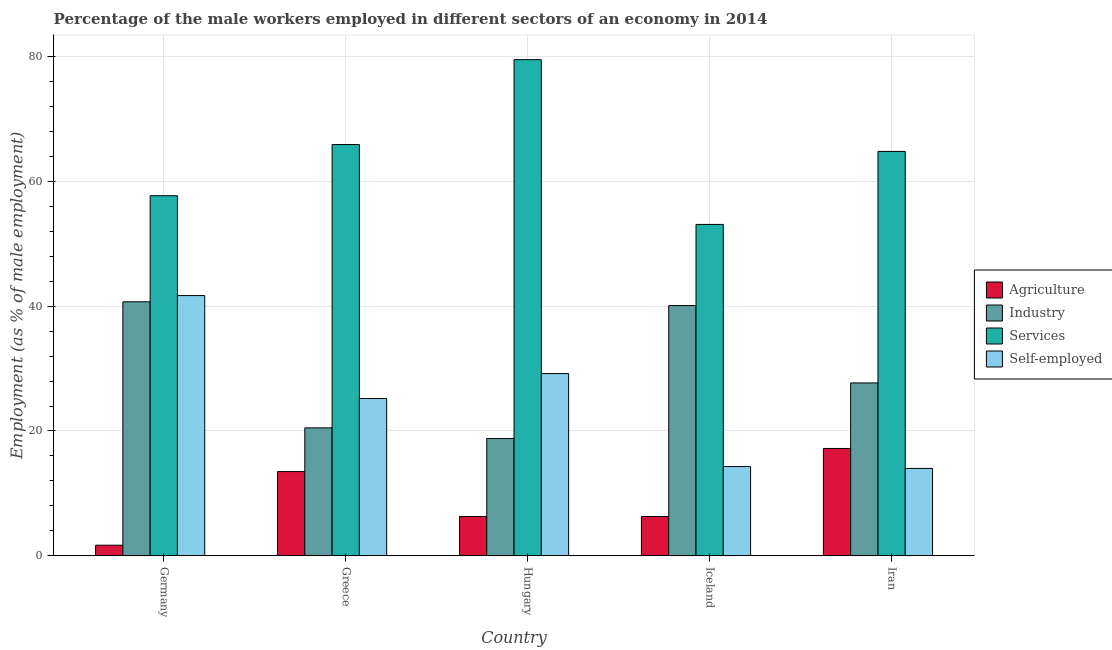How many different coloured bars are there?
Offer a very short reply. 4. Are the number of bars on each tick of the X-axis equal?
Provide a short and direct response. Yes. How many bars are there on the 3rd tick from the left?
Provide a succinct answer. 4. What is the label of the 2nd group of bars from the left?
Offer a very short reply. Greece. In how many cases, is the number of bars for a given country not equal to the number of legend labels?
Provide a short and direct response. 0. What is the percentage of male workers in industry in Iceland?
Offer a very short reply. 40.1. Across all countries, what is the maximum percentage of male workers in services?
Offer a terse response. 79.5. In which country was the percentage of male workers in agriculture maximum?
Your answer should be compact. Iran. What is the total percentage of male workers in industry in the graph?
Provide a succinct answer. 147.8. What is the difference between the percentage of male workers in industry in Iceland and that in Iran?
Your answer should be very brief. 12.4. What is the difference between the percentage of male workers in agriculture in Hungary and the percentage of self employed male workers in Germany?
Give a very brief answer. -35.4. What is the average percentage of self employed male workers per country?
Make the answer very short. 24.88. What is the difference between the percentage of male workers in industry and percentage of male workers in agriculture in Germany?
Give a very brief answer. 39. In how many countries, is the percentage of male workers in agriculture greater than 44 %?
Your answer should be compact. 0. What is the ratio of the percentage of male workers in agriculture in Greece to that in Iran?
Provide a short and direct response. 0.78. Is the percentage of male workers in agriculture in Greece less than that in Iran?
Your answer should be compact. Yes. What is the difference between the highest and the second highest percentage of male workers in industry?
Offer a terse response. 0.6. What is the difference between the highest and the lowest percentage of male workers in services?
Offer a very short reply. 26.4. In how many countries, is the percentage of self employed male workers greater than the average percentage of self employed male workers taken over all countries?
Your answer should be compact. 3. Is it the case that in every country, the sum of the percentage of male workers in industry and percentage of male workers in agriculture is greater than the sum of percentage of male workers in services and percentage of self employed male workers?
Provide a succinct answer. No. What does the 1st bar from the left in Germany represents?
Offer a very short reply. Agriculture. What does the 2nd bar from the right in Iceland represents?
Your answer should be very brief. Services. Is it the case that in every country, the sum of the percentage of male workers in agriculture and percentage of male workers in industry is greater than the percentage of male workers in services?
Give a very brief answer. No. How many countries are there in the graph?
Offer a very short reply. 5. Are the values on the major ticks of Y-axis written in scientific E-notation?
Give a very brief answer. No. Where does the legend appear in the graph?
Offer a very short reply. Center right. What is the title of the graph?
Your answer should be compact. Percentage of the male workers employed in different sectors of an economy in 2014. What is the label or title of the X-axis?
Your answer should be very brief. Country. What is the label or title of the Y-axis?
Offer a very short reply. Employment (as % of male employment). What is the Employment (as % of male employment) in Agriculture in Germany?
Provide a short and direct response. 1.7. What is the Employment (as % of male employment) in Industry in Germany?
Make the answer very short. 40.7. What is the Employment (as % of male employment) in Services in Germany?
Make the answer very short. 57.7. What is the Employment (as % of male employment) of Self-employed in Germany?
Offer a very short reply. 41.7. What is the Employment (as % of male employment) of Agriculture in Greece?
Make the answer very short. 13.5. What is the Employment (as % of male employment) of Industry in Greece?
Offer a very short reply. 20.5. What is the Employment (as % of male employment) in Services in Greece?
Your response must be concise. 65.9. What is the Employment (as % of male employment) of Self-employed in Greece?
Make the answer very short. 25.2. What is the Employment (as % of male employment) in Agriculture in Hungary?
Your answer should be compact. 6.3. What is the Employment (as % of male employment) of Industry in Hungary?
Offer a terse response. 18.8. What is the Employment (as % of male employment) in Services in Hungary?
Your response must be concise. 79.5. What is the Employment (as % of male employment) of Self-employed in Hungary?
Your answer should be compact. 29.2. What is the Employment (as % of male employment) of Agriculture in Iceland?
Give a very brief answer. 6.3. What is the Employment (as % of male employment) in Industry in Iceland?
Offer a very short reply. 40.1. What is the Employment (as % of male employment) of Services in Iceland?
Your answer should be compact. 53.1. What is the Employment (as % of male employment) of Self-employed in Iceland?
Offer a terse response. 14.3. What is the Employment (as % of male employment) in Agriculture in Iran?
Keep it short and to the point. 17.2. What is the Employment (as % of male employment) of Industry in Iran?
Give a very brief answer. 27.7. What is the Employment (as % of male employment) in Services in Iran?
Provide a succinct answer. 64.8. What is the Employment (as % of male employment) of Self-employed in Iran?
Keep it short and to the point. 14. Across all countries, what is the maximum Employment (as % of male employment) in Agriculture?
Make the answer very short. 17.2. Across all countries, what is the maximum Employment (as % of male employment) of Industry?
Ensure brevity in your answer.  40.7. Across all countries, what is the maximum Employment (as % of male employment) in Services?
Ensure brevity in your answer.  79.5. Across all countries, what is the maximum Employment (as % of male employment) of Self-employed?
Offer a terse response. 41.7. Across all countries, what is the minimum Employment (as % of male employment) in Agriculture?
Your answer should be compact. 1.7. Across all countries, what is the minimum Employment (as % of male employment) of Industry?
Your response must be concise. 18.8. Across all countries, what is the minimum Employment (as % of male employment) in Services?
Your response must be concise. 53.1. Across all countries, what is the minimum Employment (as % of male employment) of Self-employed?
Provide a short and direct response. 14. What is the total Employment (as % of male employment) in Industry in the graph?
Your answer should be very brief. 147.8. What is the total Employment (as % of male employment) of Services in the graph?
Give a very brief answer. 321. What is the total Employment (as % of male employment) in Self-employed in the graph?
Offer a terse response. 124.4. What is the difference between the Employment (as % of male employment) of Agriculture in Germany and that in Greece?
Provide a short and direct response. -11.8. What is the difference between the Employment (as % of male employment) of Industry in Germany and that in Greece?
Offer a terse response. 20.2. What is the difference between the Employment (as % of male employment) in Services in Germany and that in Greece?
Keep it short and to the point. -8.2. What is the difference between the Employment (as % of male employment) in Self-employed in Germany and that in Greece?
Give a very brief answer. 16.5. What is the difference between the Employment (as % of male employment) of Industry in Germany and that in Hungary?
Keep it short and to the point. 21.9. What is the difference between the Employment (as % of male employment) in Services in Germany and that in Hungary?
Provide a short and direct response. -21.8. What is the difference between the Employment (as % of male employment) of Self-employed in Germany and that in Iceland?
Provide a succinct answer. 27.4. What is the difference between the Employment (as % of male employment) in Agriculture in Germany and that in Iran?
Keep it short and to the point. -15.5. What is the difference between the Employment (as % of male employment) of Industry in Germany and that in Iran?
Offer a terse response. 13. What is the difference between the Employment (as % of male employment) of Self-employed in Germany and that in Iran?
Offer a very short reply. 27.7. What is the difference between the Employment (as % of male employment) in Services in Greece and that in Hungary?
Offer a terse response. -13.6. What is the difference between the Employment (as % of male employment) of Self-employed in Greece and that in Hungary?
Provide a short and direct response. -4. What is the difference between the Employment (as % of male employment) of Industry in Greece and that in Iceland?
Give a very brief answer. -19.6. What is the difference between the Employment (as % of male employment) in Services in Greece and that in Iceland?
Keep it short and to the point. 12.8. What is the difference between the Employment (as % of male employment) of Agriculture in Greece and that in Iran?
Provide a succinct answer. -3.7. What is the difference between the Employment (as % of male employment) of Industry in Greece and that in Iran?
Ensure brevity in your answer.  -7.2. What is the difference between the Employment (as % of male employment) in Self-employed in Greece and that in Iran?
Your answer should be compact. 11.2. What is the difference between the Employment (as % of male employment) in Industry in Hungary and that in Iceland?
Make the answer very short. -21.3. What is the difference between the Employment (as % of male employment) of Services in Hungary and that in Iceland?
Provide a short and direct response. 26.4. What is the difference between the Employment (as % of male employment) of Self-employed in Hungary and that in Iceland?
Keep it short and to the point. 14.9. What is the difference between the Employment (as % of male employment) of Self-employed in Hungary and that in Iran?
Provide a short and direct response. 15.2. What is the difference between the Employment (as % of male employment) of Self-employed in Iceland and that in Iran?
Your answer should be very brief. 0.3. What is the difference between the Employment (as % of male employment) in Agriculture in Germany and the Employment (as % of male employment) in Industry in Greece?
Make the answer very short. -18.8. What is the difference between the Employment (as % of male employment) of Agriculture in Germany and the Employment (as % of male employment) of Services in Greece?
Offer a terse response. -64.2. What is the difference between the Employment (as % of male employment) of Agriculture in Germany and the Employment (as % of male employment) of Self-employed in Greece?
Your answer should be very brief. -23.5. What is the difference between the Employment (as % of male employment) of Industry in Germany and the Employment (as % of male employment) of Services in Greece?
Your response must be concise. -25.2. What is the difference between the Employment (as % of male employment) in Services in Germany and the Employment (as % of male employment) in Self-employed in Greece?
Provide a succinct answer. 32.5. What is the difference between the Employment (as % of male employment) in Agriculture in Germany and the Employment (as % of male employment) in Industry in Hungary?
Offer a very short reply. -17.1. What is the difference between the Employment (as % of male employment) of Agriculture in Germany and the Employment (as % of male employment) of Services in Hungary?
Provide a short and direct response. -77.8. What is the difference between the Employment (as % of male employment) in Agriculture in Germany and the Employment (as % of male employment) in Self-employed in Hungary?
Provide a short and direct response. -27.5. What is the difference between the Employment (as % of male employment) in Industry in Germany and the Employment (as % of male employment) in Services in Hungary?
Your answer should be compact. -38.8. What is the difference between the Employment (as % of male employment) of Services in Germany and the Employment (as % of male employment) of Self-employed in Hungary?
Keep it short and to the point. 28.5. What is the difference between the Employment (as % of male employment) in Agriculture in Germany and the Employment (as % of male employment) in Industry in Iceland?
Provide a short and direct response. -38.4. What is the difference between the Employment (as % of male employment) of Agriculture in Germany and the Employment (as % of male employment) of Services in Iceland?
Keep it short and to the point. -51.4. What is the difference between the Employment (as % of male employment) in Agriculture in Germany and the Employment (as % of male employment) in Self-employed in Iceland?
Your answer should be compact. -12.6. What is the difference between the Employment (as % of male employment) in Industry in Germany and the Employment (as % of male employment) in Self-employed in Iceland?
Offer a terse response. 26.4. What is the difference between the Employment (as % of male employment) of Services in Germany and the Employment (as % of male employment) of Self-employed in Iceland?
Provide a succinct answer. 43.4. What is the difference between the Employment (as % of male employment) in Agriculture in Germany and the Employment (as % of male employment) in Services in Iran?
Your answer should be compact. -63.1. What is the difference between the Employment (as % of male employment) in Agriculture in Germany and the Employment (as % of male employment) in Self-employed in Iran?
Ensure brevity in your answer.  -12.3. What is the difference between the Employment (as % of male employment) in Industry in Germany and the Employment (as % of male employment) in Services in Iran?
Provide a succinct answer. -24.1. What is the difference between the Employment (as % of male employment) in Industry in Germany and the Employment (as % of male employment) in Self-employed in Iran?
Offer a terse response. 26.7. What is the difference between the Employment (as % of male employment) in Services in Germany and the Employment (as % of male employment) in Self-employed in Iran?
Give a very brief answer. 43.7. What is the difference between the Employment (as % of male employment) of Agriculture in Greece and the Employment (as % of male employment) of Services in Hungary?
Offer a very short reply. -66. What is the difference between the Employment (as % of male employment) of Agriculture in Greece and the Employment (as % of male employment) of Self-employed in Hungary?
Provide a succinct answer. -15.7. What is the difference between the Employment (as % of male employment) in Industry in Greece and the Employment (as % of male employment) in Services in Hungary?
Your response must be concise. -59. What is the difference between the Employment (as % of male employment) in Industry in Greece and the Employment (as % of male employment) in Self-employed in Hungary?
Offer a terse response. -8.7. What is the difference between the Employment (as % of male employment) in Services in Greece and the Employment (as % of male employment) in Self-employed in Hungary?
Offer a very short reply. 36.7. What is the difference between the Employment (as % of male employment) in Agriculture in Greece and the Employment (as % of male employment) in Industry in Iceland?
Make the answer very short. -26.6. What is the difference between the Employment (as % of male employment) of Agriculture in Greece and the Employment (as % of male employment) of Services in Iceland?
Provide a short and direct response. -39.6. What is the difference between the Employment (as % of male employment) in Agriculture in Greece and the Employment (as % of male employment) in Self-employed in Iceland?
Keep it short and to the point. -0.8. What is the difference between the Employment (as % of male employment) in Industry in Greece and the Employment (as % of male employment) in Services in Iceland?
Give a very brief answer. -32.6. What is the difference between the Employment (as % of male employment) of Industry in Greece and the Employment (as % of male employment) of Self-employed in Iceland?
Your answer should be compact. 6.2. What is the difference between the Employment (as % of male employment) of Services in Greece and the Employment (as % of male employment) of Self-employed in Iceland?
Provide a short and direct response. 51.6. What is the difference between the Employment (as % of male employment) in Agriculture in Greece and the Employment (as % of male employment) in Industry in Iran?
Provide a short and direct response. -14.2. What is the difference between the Employment (as % of male employment) in Agriculture in Greece and the Employment (as % of male employment) in Services in Iran?
Your answer should be compact. -51.3. What is the difference between the Employment (as % of male employment) of Agriculture in Greece and the Employment (as % of male employment) of Self-employed in Iran?
Your response must be concise. -0.5. What is the difference between the Employment (as % of male employment) in Industry in Greece and the Employment (as % of male employment) in Services in Iran?
Your answer should be very brief. -44.3. What is the difference between the Employment (as % of male employment) in Services in Greece and the Employment (as % of male employment) in Self-employed in Iran?
Your answer should be compact. 51.9. What is the difference between the Employment (as % of male employment) of Agriculture in Hungary and the Employment (as % of male employment) of Industry in Iceland?
Make the answer very short. -33.8. What is the difference between the Employment (as % of male employment) in Agriculture in Hungary and the Employment (as % of male employment) in Services in Iceland?
Keep it short and to the point. -46.8. What is the difference between the Employment (as % of male employment) of Agriculture in Hungary and the Employment (as % of male employment) of Self-employed in Iceland?
Provide a short and direct response. -8. What is the difference between the Employment (as % of male employment) of Industry in Hungary and the Employment (as % of male employment) of Services in Iceland?
Provide a short and direct response. -34.3. What is the difference between the Employment (as % of male employment) in Services in Hungary and the Employment (as % of male employment) in Self-employed in Iceland?
Your response must be concise. 65.2. What is the difference between the Employment (as % of male employment) in Agriculture in Hungary and the Employment (as % of male employment) in Industry in Iran?
Your answer should be compact. -21.4. What is the difference between the Employment (as % of male employment) of Agriculture in Hungary and the Employment (as % of male employment) of Services in Iran?
Your answer should be compact. -58.5. What is the difference between the Employment (as % of male employment) in Industry in Hungary and the Employment (as % of male employment) in Services in Iran?
Your response must be concise. -46. What is the difference between the Employment (as % of male employment) in Services in Hungary and the Employment (as % of male employment) in Self-employed in Iran?
Your response must be concise. 65.5. What is the difference between the Employment (as % of male employment) in Agriculture in Iceland and the Employment (as % of male employment) in Industry in Iran?
Offer a very short reply. -21.4. What is the difference between the Employment (as % of male employment) in Agriculture in Iceland and the Employment (as % of male employment) in Services in Iran?
Provide a short and direct response. -58.5. What is the difference between the Employment (as % of male employment) in Industry in Iceland and the Employment (as % of male employment) in Services in Iran?
Your answer should be very brief. -24.7. What is the difference between the Employment (as % of male employment) of Industry in Iceland and the Employment (as % of male employment) of Self-employed in Iran?
Provide a short and direct response. 26.1. What is the difference between the Employment (as % of male employment) of Services in Iceland and the Employment (as % of male employment) of Self-employed in Iran?
Offer a terse response. 39.1. What is the average Employment (as % of male employment) of Industry per country?
Provide a succinct answer. 29.56. What is the average Employment (as % of male employment) of Services per country?
Provide a short and direct response. 64.2. What is the average Employment (as % of male employment) in Self-employed per country?
Give a very brief answer. 24.88. What is the difference between the Employment (as % of male employment) of Agriculture and Employment (as % of male employment) of Industry in Germany?
Your answer should be compact. -39. What is the difference between the Employment (as % of male employment) of Agriculture and Employment (as % of male employment) of Services in Germany?
Offer a very short reply. -56. What is the difference between the Employment (as % of male employment) in Agriculture and Employment (as % of male employment) in Self-employed in Germany?
Keep it short and to the point. -40. What is the difference between the Employment (as % of male employment) in Industry and Employment (as % of male employment) in Services in Germany?
Your answer should be compact. -17. What is the difference between the Employment (as % of male employment) in Industry and Employment (as % of male employment) in Self-employed in Germany?
Your answer should be compact. -1. What is the difference between the Employment (as % of male employment) of Services and Employment (as % of male employment) of Self-employed in Germany?
Your response must be concise. 16. What is the difference between the Employment (as % of male employment) of Agriculture and Employment (as % of male employment) of Industry in Greece?
Offer a terse response. -7. What is the difference between the Employment (as % of male employment) of Agriculture and Employment (as % of male employment) of Services in Greece?
Your response must be concise. -52.4. What is the difference between the Employment (as % of male employment) of Agriculture and Employment (as % of male employment) of Self-employed in Greece?
Provide a short and direct response. -11.7. What is the difference between the Employment (as % of male employment) of Industry and Employment (as % of male employment) of Services in Greece?
Your response must be concise. -45.4. What is the difference between the Employment (as % of male employment) of Services and Employment (as % of male employment) of Self-employed in Greece?
Offer a terse response. 40.7. What is the difference between the Employment (as % of male employment) in Agriculture and Employment (as % of male employment) in Industry in Hungary?
Your answer should be very brief. -12.5. What is the difference between the Employment (as % of male employment) of Agriculture and Employment (as % of male employment) of Services in Hungary?
Offer a very short reply. -73.2. What is the difference between the Employment (as % of male employment) in Agriculture and Employment (as % of male employment) in Self-employed in Hungary?
Keep it short and to the point. -22.9. What is the difference between the Employment (as % of male employment) of Industry and Employment (as % of male employment) of Services in Hungary?
Give a very brief answer. -60.7. What is the difference between the Employment (as % of male employment) of Industry and Employment (as % of male employment) of Self-employed in Hungary?
Your answer should be very brief. -10.4. What is the difference between the Employment (as % of male employment) in Services and Employment (as % of male employment) in Self-employed in Hungary?
Your answer should be compact. 50.3. What is the difference between the Employment (as % of male employment) of Agriculture and Employment (as % of male employment) of Industry in Iceland?
Ensure brevity in your answer.  -33.8. What is the difference between the Employment (as % of male employment) in Agriculture and Employment (as % of male employment) in Services in Iceland?
Your answer should be compact. -46.8. What is the difference between the Employment (as % of male employment) of Industry and Employment (as % of male employment) of Self-employed in Iceland?
Make the answer very short. 25.8. What is the difference between the Employment (as % of male employment) in Services and Employment (as % of male employment) in Self-employed in Iceland?
Your answer should be compact. 38.8. What is the difference between the Employment (as % of male employment) in Agriculture and Employment (as % of male employment) in Industry in Iran?
Make the answer very short. -10.5. What is the difference between the Employment (as % of male employment) of Agriculture and Employment (as % of male employment) of Services in Iran?
Ensure brevity in your answer.  -47.6. What is the difference between the Employment (as % of male employment) in Agriculture and Employment (as % of male employment) in Self-employed in Iran?
Give a very brief answer. 3.2. What is the difference between the Employment (as % of male employment) of Industry and Employment (as % of male employment) of Services in Iran?
Ensure brevity in your answer.  -37.1. What is the difference between the Employment (as % of male employment) in Services and Employment (as % of male employment) in Self-employed in Iran?
Ensure brevity in your answer.  50.8. What is the ratio of the Employment (as % of male employment) of Agriculture in Germany to that in Greece?
Your response must be concise. 0.13. What is the ratio of the Employment (as % of male employment) in Industry in Germany to that in Greece?
Ensure brevity in your answer.  1.99. What is the ratio of the Employment (as % of male employment) of Services in Germany to that in Greece?
Offer a very short reply. 0.88. What is the ratio of the Employment (as % of male employment) in Self-employed in Germany to that in Greece?
Keep it short and to the point. 1.65. What is the ratio of the Employment (as % of male employment) of Agriculture in Germany to that in Hungary?
Offer a terse response. 0.27. What is the ratio of the Employment (as % of male employment) of Industry in Germany to that in Hungary?
Offer a very short reply. 2.16. What is the ratio of the Employment (as % of male employment) of Services in Germany to that in Hungary?
Your answer should be very brief. 0.73. What is the ratio of the Employment (as % of male employment) in Self-employed in Germany to that in Hungary?
Your response must be concise. 1.43. What is the ratio of the Employment (as % of male employment) in Agriculture in Germany to that in Iceland?
Provide a short and direct response. 0.27. What is the ratio of the Employment (as % of male employment) of Services in Germany to that in Iceland?
Your answer should be very brief. 1.09. What is the ratio of the Employment (as % of male employment) of Self-employed in Germany to that in Iceland?
Your answer should be very brief. 2.92. What is the ratio of the Employment (as % of male employment) in Agriculture in Germany to that in Iran?
Provide a succinct answer. 0.1. What is the ratio of the Employment (as % of male employment) in Industry in Germany to that in Iran?
Provide a short and direct response. 1.47. What is the ratio of the Employment (as % of male employment) in Services in Germany to that in Iran?
Offer a very short reply. 0.89. What is the ratio of the Employment (as % of male employment) in Self-employed in Germany to that in Iran?
Ensure brevity in your answer.  2.98. What is the ratio of the Employment (as % of male employment) in Agriculture in Greece to that in Hungary?
Make the answer very short. 2.14. What is the ratio of the Employment (as % of male employment) in Industry in Greece to that in Hungary?
Offer a very short reply. 1.09. What is the ratio of the Employment (as % of male employment) in Services in Greece to that in Hungary?
Provide a short and direct response. 0.83. What is the ratio of the Employment (as % of male employment) of Self-employed in Greece to that in Hungary?
Provide a succinct answer. 0.86. What is the ratio of the Employment (as % of male employment) of Agriculture in Greece to that in Iceland?
Your answer should be compact. 2.14. What is the ratio of the Employment (as % of male employment) in Industry in Greece to that in Iceland?
Provide a short and direct response. 0.51. What is the ratio of the Employment (as % of male employment) in Services in Greece to that in Iceland?
Provide a short and direct response. 1.24. What is the ratio of the Employment (as % of male employment) in Self-employed in Greece to that in Iceland?
Offer a very short reply. 1.76. What is the ratio of the Employment (as % of male employment) of Agriculture in Greece to that in Iran?
Your answer should be compact. 0.78. What is the ratio of the Employment (as % of male employment) of Industry in Greece to that in Iran?
Offer a terse response. 0.74. What is the ratio of the Employment (as % of male employment) in Services in Greece to that in Iran?
Offer a terse response. 1.02. What is the ratio of the Employment (as % of male employment) of Self-employed in Greece to that in Iran?
Provide a short and direct response. 1.8. What is the ratio of the Employment (as % of male employment) of Industry in Hungary to that in Iceland?
Your response must be concise. 0.47. What is the ratio of the Employment (as % of male employment) in Services in Hungary to that in Iceland?
Make the answer very short. 1.5. What is the ratio of the Employment (as % of male employment) in Self-employed in Hungary to that in Iceland?
Provide a succinct answer. 2.04. What is the ratio of the Employment (as % of male employment) of Agriculture in Hungary to that in Iran?
Your response must be concise. 0.37. What is the ratio of the Employment (as % of male employment) in Industry in Hungary to that in Iran?
Your response must be concise. 0.68. What is the ratio of the Employment (as % of male employment) in Services in Hungary to that in Iran?
Offer a very short reply. 1.23. What is the ratio of the Employment (as % of male employment) in Self-employed in Hungary to that in Iran?
Make the answer very short. 2.09. What is the ratio of the Employment (as % of male employment) in Agriculture in Iceland to that in Iran?
Offer a terse response. 0.37. What is the ratio of the Employment (as % of male employment) of Industry in Iceland to that in Iran?
Your response must be concise. 1.45. What is the ratio of the Employment (as % of male employment) in Services in Iceland to that in Iran?
Make the answer very short. 0.82. What is the ratio of the Employment (as % of male employment) in Self-employed in Iceland to that in Iran?
Ensure brevity in your answer.  1.02. What is the difference between the highest and the second highest Employment (as % of male employment) in Agriculture?
Provide a succinct answer. 3.7. What is the difference between the highest and the lowest Employment (as % of male employment) in Industry?
Make the answer very short. 21.9. What is the difference between the highest and the lowest Employment (as % of male employment) in Services?
Provide a short and direct response. 26.4. What is the difference between the highest and the lowest Employment (as % of male employment) of Self-employed?
Provide a succinct answer. 27.7. 